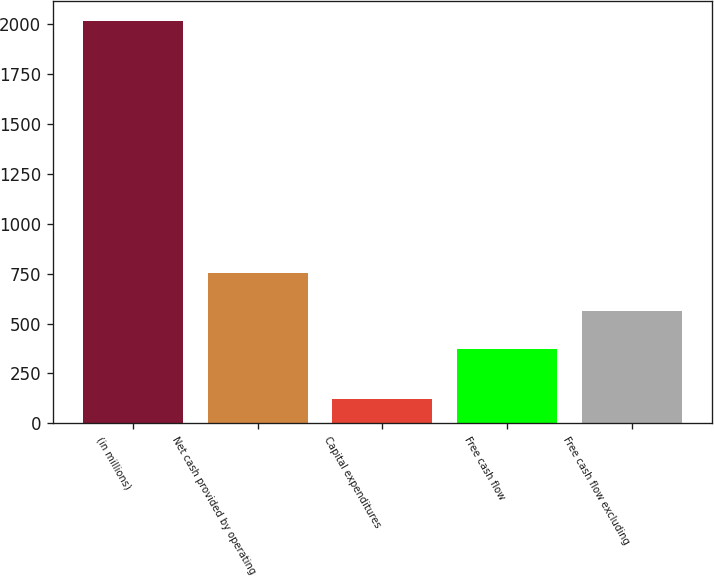Convert chart to OTSL. <chart><loc_0><loc_0><loc_500><loc_500><bar_chart><fcel>(in millions)<fcel>Net cash provided by operating<fcel>Capital expenditures<fcel>Free cash flow<fcel>Free cash flow excluding<nl><fcel>2016<fcel>751.4<fcel>124<fcel>373<fcel>562.2<nl></chart> 